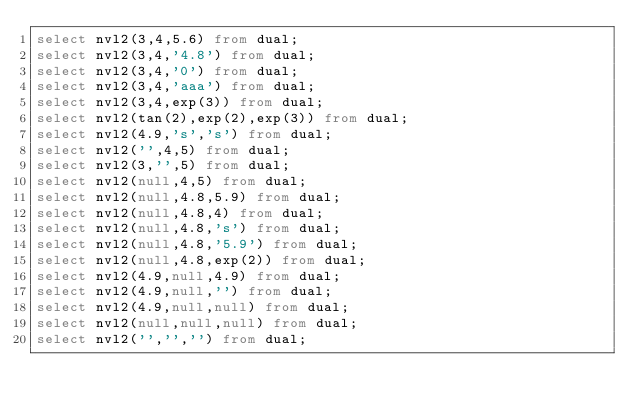Convert code to text. <code><loc_0><loc_0><loc_500><loc_500><_SQL_>select nvl2(3,4,5.6) from dual;
select nvl2(3,4,'4.8') from dual;
select nvl2(3,4,'0') from dual;
select nvl2(3,4,'aaa') from dual;
select nvl2(3,4,exp(3)) from dual;
select nvl2(tan(2),exp(2),exp(3)) from dual;
select nvl2(4.9,'s','s') from dual;
select nvl2('',4,5) from dual;
select nvl2(3,'',5) from dual;
select nvl2(null,4,5) from dual;
select nvl2(null,4.8,5.9) from dual;
select nvl2(null,4.8,4) from dual;
select nvl2(null,4.8,'s') from dual;
select nvl2(null,4.8,'5.9') from dual;
select nvl2(null,4.8,exp(2)) from dual;
select nvl2(4.9,null,4.9) from dual;
select nvl2(4.9,null,'') from dual;
select nvl2(4.9,null,null) from dual;
select nvl2(null,null,null) from dual;
select nvl2('','','') from dual;
</code> 